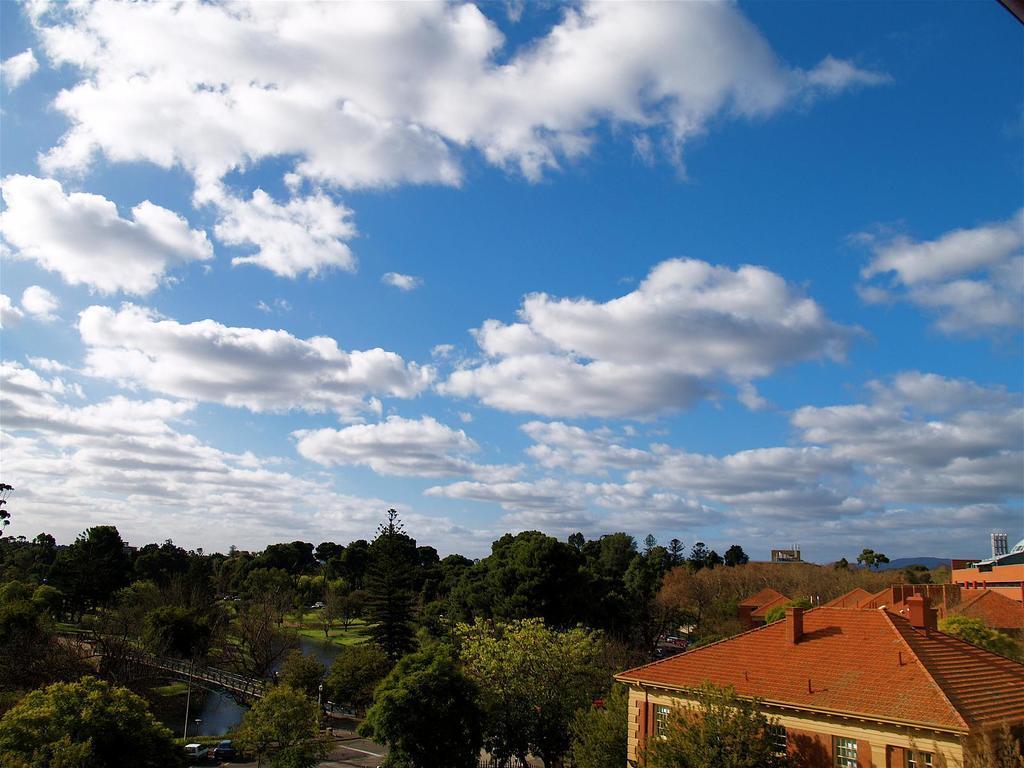Can you describe this image briefly? In this picture we can see few houses, poles and trees, and also we can see a bridge over the water, in the background we can find clouds. 